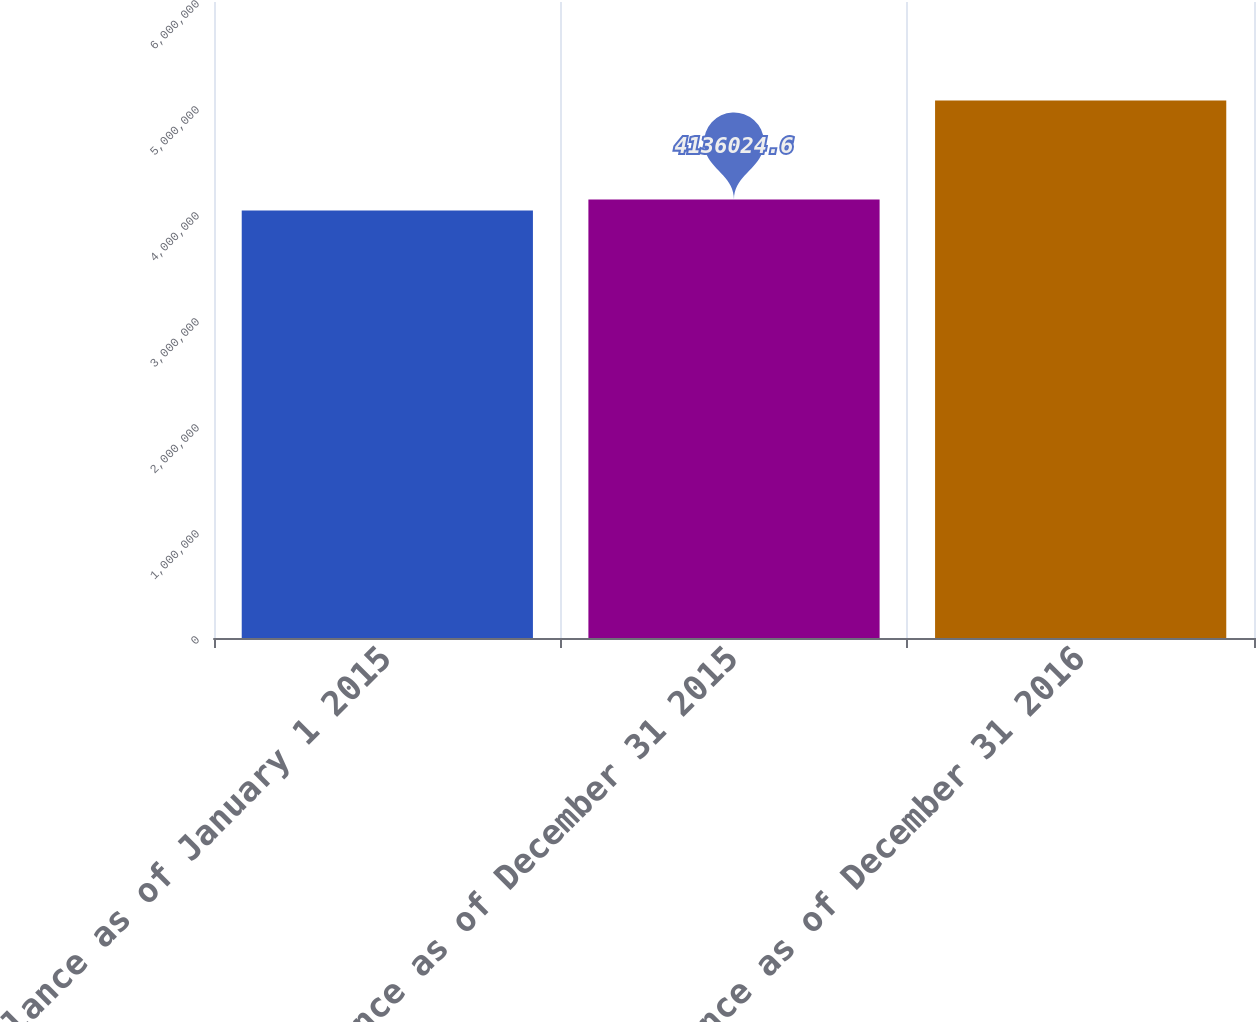<chart> <loc_0><loc_0><loc_500><loc_500><bar_chart><fcel>Balance as of January 1 2015<fcel>Balance as of December 31 2015<fcel>Balance as of December 31 2016<nl><fcel>4.03217e+06<fcel>4.13602e+06<fcel>5.07068e+06<nl></chart> 